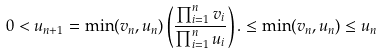<formula> <loc_0><loc_0><loc_500><loc_500>0 < u _ { n + 1 } = \min ( v _ { n } , u _ { n } ) \left ( \frac { \prod _ { i = 1 } ^ { n } v _ { i } } { \prod _ { i = 1 } ^ { n } u _ { i } } \right ) . \leq \min ( v _ { n } , u _ { n } ) \leq u _ { n }</formula> 